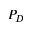<formula> <loc_0><loc_0><loc_500><loc_500>P _ { D }</formula> 